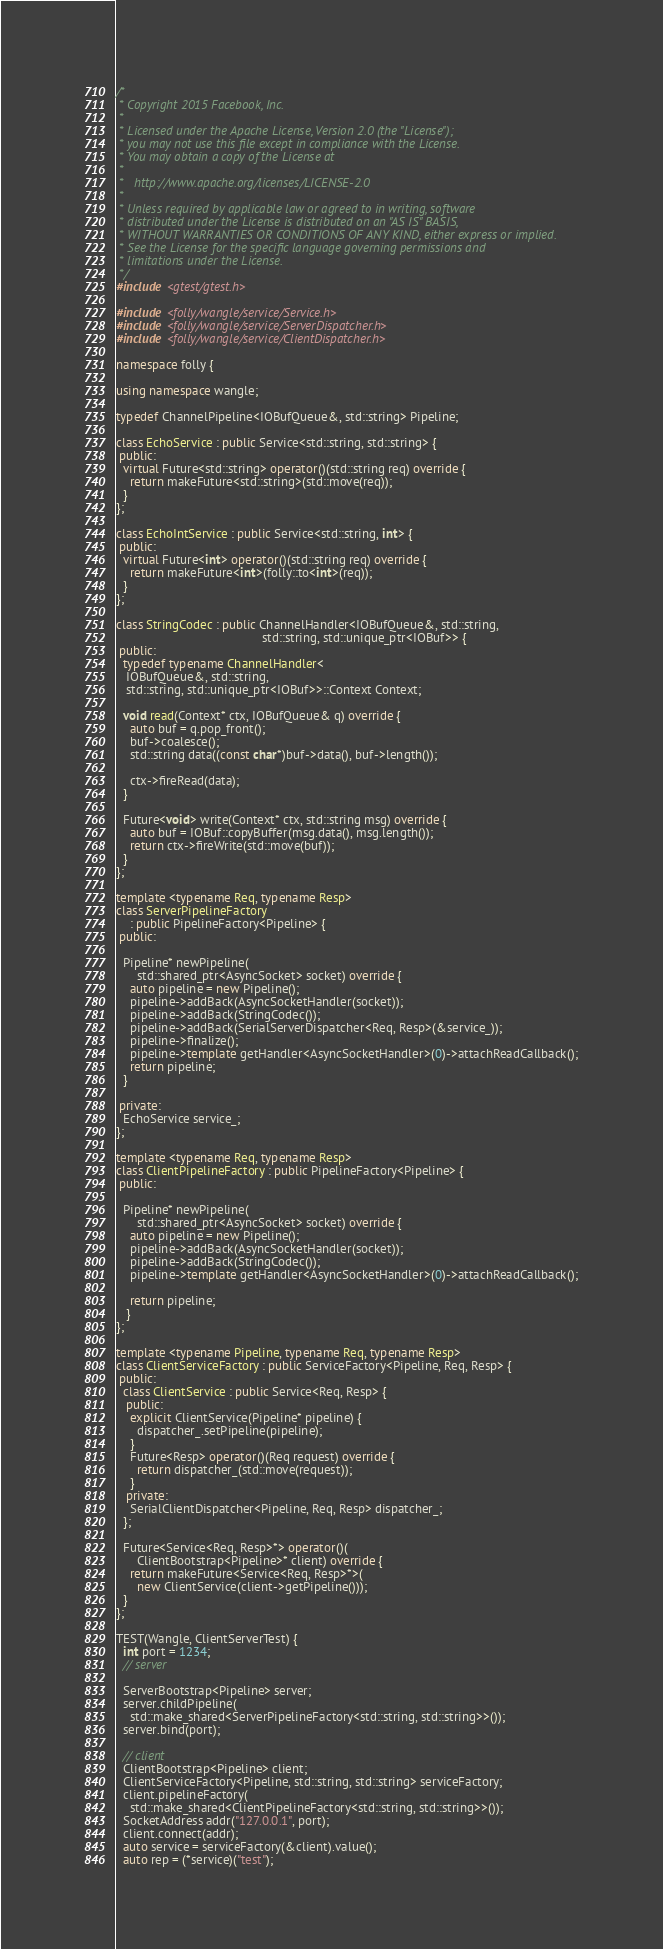Convert code to text. <code><loc_0><loc_0><loc_500><loc_500><_C++_>/*
 * Copyright 2015 Facebook, Inc.
 *
 * Licensed under the Apache License, Version 2.0 (the "License");
 * you may not use this file except in compliance with the License.
 * You may obtain a copy of the License at
 *
 *   http://www.apache.org/licenses/LICENSE-2.0
 *
 * Unless required by applicable law or agreed to in writing, software
 * distributed under the License is distributed on an "AS IS" BASIS,
 * WITHOUT WARRANTIES OR CONDITIONS OF ANY KIND, either express or implied.
 * See the License for the specific language governing permissions and
 * limitations under the License.
 */
#include <gtest/gtest.h>

#include <folly/wangle/service/Service.h>
#include <folly/wangle/service/ServerDispatcher.h>
#include <folly/wangle/service/ClientDispatcher.h>

namespace folly {

using namespace wangle;

typedef ChannelPipeline<IOBufQueue&, std::string> Pipeline;

class EchoService : public Service<std::string, std::string> {
 public:
  virtual Future<std::string> operator()(std::string req) override {
    return makeFuture<std::string>(std::move(req));
  }
};

class EchoIntService : public Service<std::string, int> {
 public:
  virtual Future<int> operator()(std::string req) override {
    return makeFuture<int>(folly::to<int>(req));
  }
};

class StringCodec : public ChannelHandler<IOBufQueue&, std::string,
                                          std::string, std::unique_ptr<IOBuf>> {
 public:
  typedef typename ChannelHandler<
   IOBufQueue&, std::string,
   std::string, std::unique_ptr<IOBuf>>::Context Context;

  void read(Context* ctx, IOBufQueue& q) override {
    auto buf = q.pop_front();
    buf->coalesce();
    std::string data((const char*)buf->data(), buf->length());

    ctx->fireRead(data);
  }

  Future<void> write(Context* ctx, std::string msg) override {
    auto buf = IOBuf::copyBuffer(msg.data(), msg.length());
    return ctx->fireWrite(std::move(buf));
  }
};

template <typename Req, typename Resp>
class ServerPipelineFactory
    : public PipelineFactory<Pipeline> {
 public:

  Pipeline* newPipeline(
      std::shared_ptr<AsyncSocket> socket) override {
    auto pipeline = new Pipeline();
    pipeline->addBack(AsyncSocketHandler(socket));
    pipeline->addBack(StringCodec());
    pipeline->addBack(SerialServerDispatcher<Req, Resp>(&service_));
    pipeline->finalize();
    pipeline->template getHandler<AsyncSocketHandler>(0)->attachReadCallback();
    return pipeline;
  }

 private:
  EchoService service_;
};

template <typename Req, typename Resp>
class ClientPipelineFactory : public PipelineFactory<Pipeline> {
 public:

  Pipeline* newPipeline(
      std::shared_ptr<AsyncSocket> socket) override {
    auto pipeline = new Pipeline();
    pipeline->addBack(AsyncSocketHandler(socket));
    pipeline->addBack(StringCodec());
    pipeline->template getHandler<AsyncSocketHandler>(0)->attachReadCallback();

    return pipeline;
   }
};

template <typename Pipeline, typename Req, typename Resp>
class ClientServiceFactory : public ServiceFactory<Pipeline, Req, Resp> {
 public:
  class ClientService : public Service<Req, Resp> {
   public:
    explicit ClientService(Pipeline* pipeline) {
      dispatcher_.setPipeline(pipeline);
    }
    Future<Resp> operator()(Req request) override {
      return dispatcher_(std::move(request));
    }
   private:
    SerialClientDispatcher<Pipeline, Req, Resp> dispatcher_;
  };

  Future<Service<Req, Resp>*> operator()(
      ClientBootstrap<Pipeline>* client) override {
    return makeFuture<Service<Req, Resp>*>(
      new ClientService(client->getPipeline()));
  }
};

TEST(Wangle, ClientServerTest) {
  int port = 1234;
  // server

  ServerBootstrap<Pipeline> server;
  server.childPipeline(
    std::make_shared<ServerPipelineFactory<std::string, std::string>>());
  server.bind(port);

  // client
  ClientBootstrap<Pipeline> client;
  ClientServiceFactory<Pipeline, std::string, std::string> serviceFactory;
  client.pipelineFactory(
    std::make_shared<ClientPipelineFactory<std::string, std::string>>());
  SocketAddress addr("127.0.0.1", port);
  client.connect(addr);
  auto service = serviceFactory(&client).value();
  auto rep = (*service)("test");
</code> 